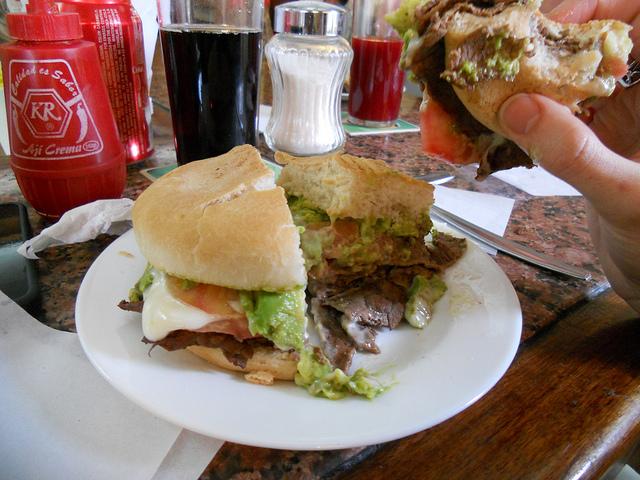What kind of burger is that?
Answer briefly. Hamburger. How many condiment containers are shown?
Quick response, please. 2. Is there meat in the sandwich?
Give a very brief answer. Yes. What kind of soda is that?
Be succinct. Coke. What is on the sandwich, besides the lettuce?
Concise answer only. Cheese. 